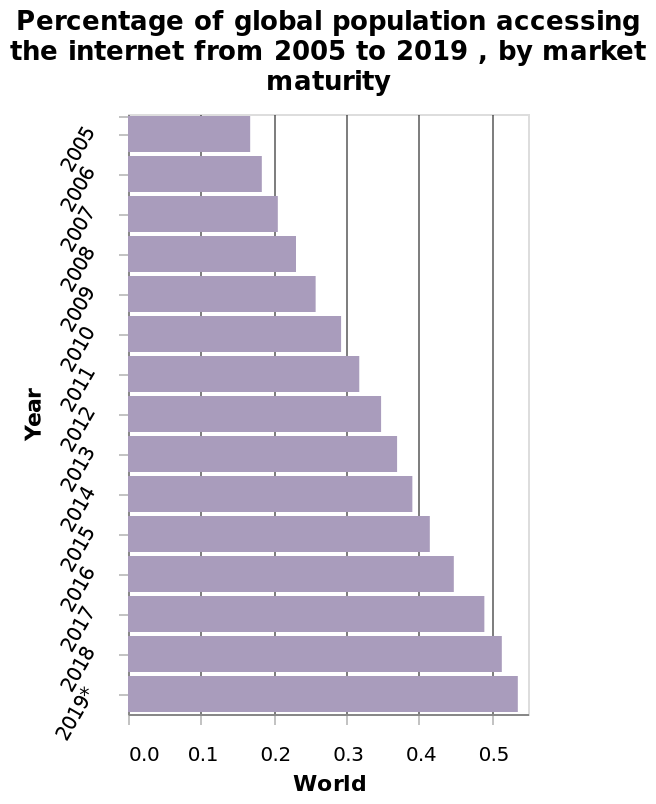<image>
Offer a thorough analysis of the image. The number of the population accessing the internet increased every year. The largest increase of population accessing the internet was in 2017. Has the number of people accessing the internet been increasing over the years?  Yes, the number of the population accessing the internet has been increasing every year. 